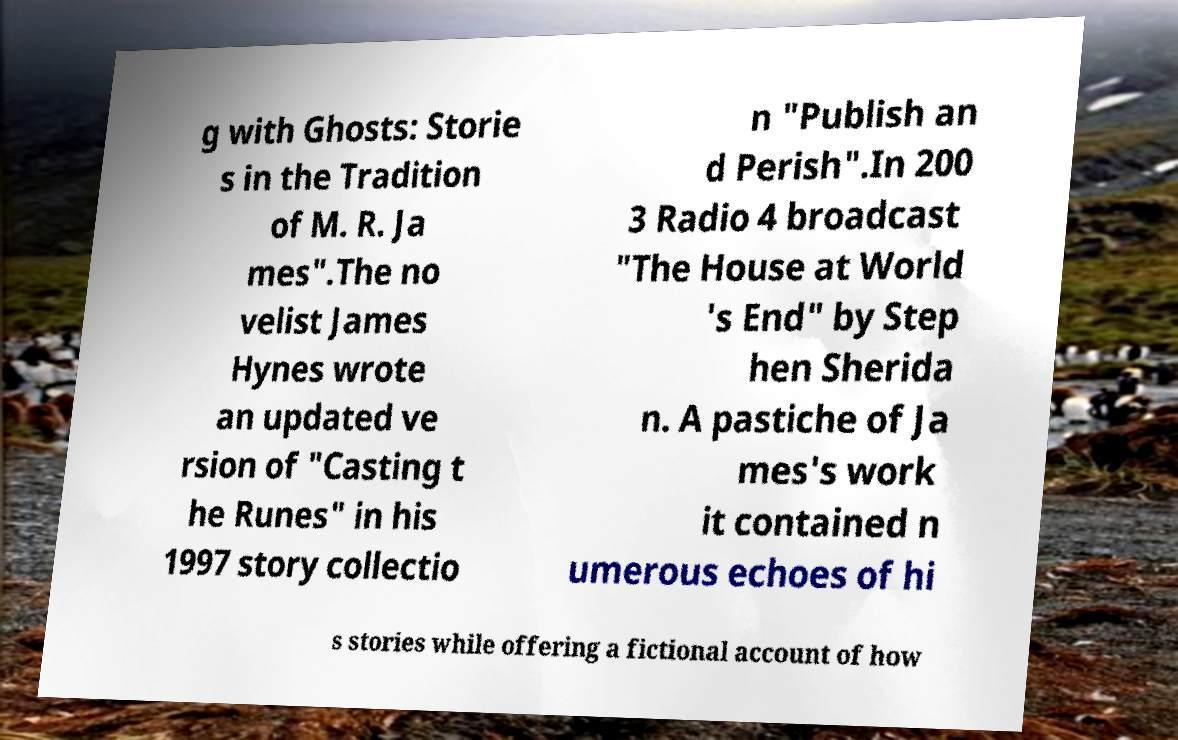Could you extract and type out the text from this image? g with Ghosts: Storie s in the Tradition of M. R. Ja mes".The no velist James Hynes wrote an updated ve rsion of "Casting t he Runes" in his 1997 story collectio n "Publish an d Perish".In 200 3 Radio 4 broadcast "The House at World 's End" by Step hen Sherida n. A pastiche of Ja mes's work it contained n umerous echoes of hi s stories while offering a fictional account of how 